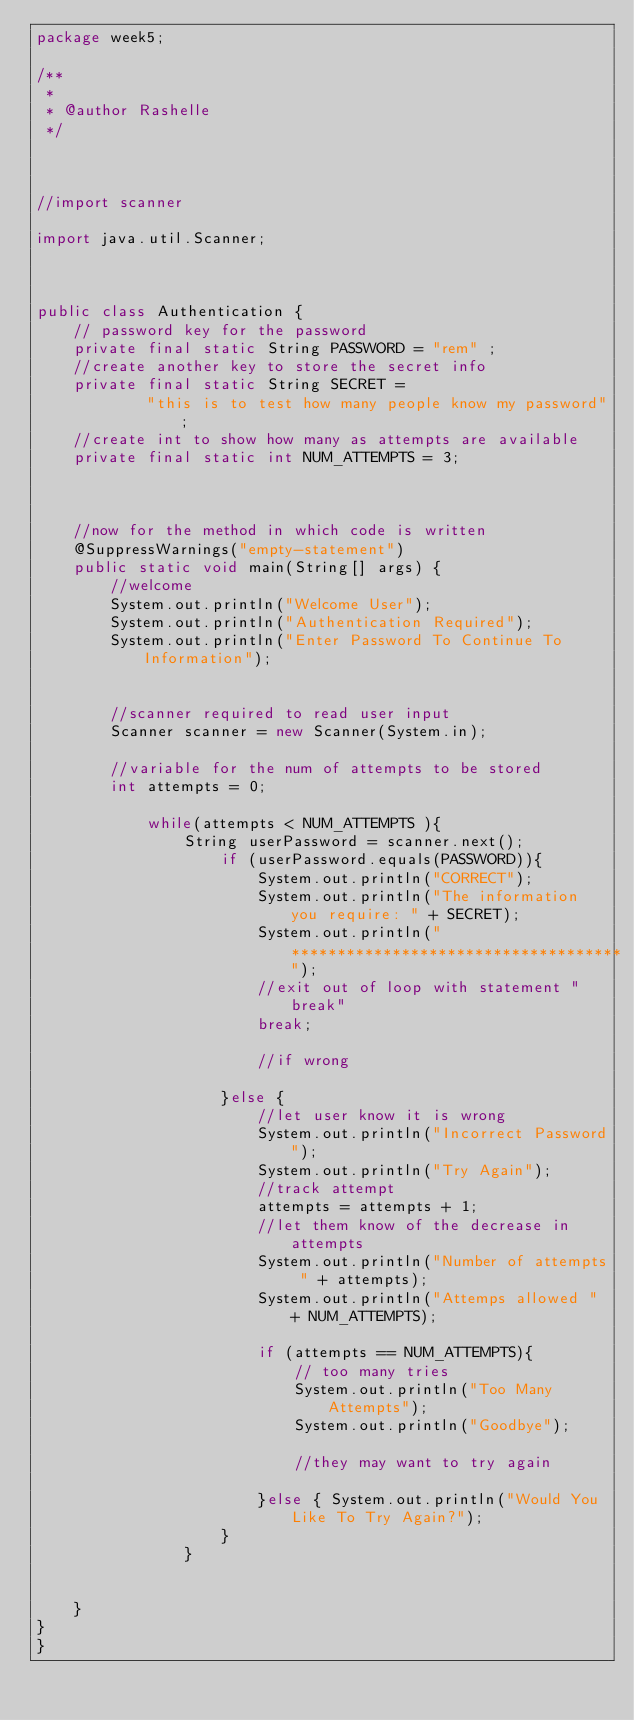Convert code to text. <code><loc_0><loc_0><loc_500><loc_500><_Java_>package week5;

/**
 *
 * @author Rashelle
 */



//import scanner

import java.util.Scanner;



public class Authentication {
    // password key for the password
    private final static String PASSWORD = "rem" ;
    //create another key to store the secret info
    private final static String SECRET = 
            "this is to test how many people know my password";
    //create int to show how many as attempts are available
    private final static int NUM_ATTEMPTS = 3;
    
   
    
    //now for the method in which code is written
    @SuppressWarnings("empty-statement")
    public static void main(String[] args) {
        //welcome
        System.out.println("Welcome User");
        System.out.println("Authentication Required");
        System.out.println("Enter Password To Continue To Information");
        
        
        //scanner required to read user input
        Scanner scanner = new Scanner(System.in);
        
        //variable for the num of attempts to be stored
        int attempts = 0;
        
            while(attempts < NUM_ATTEMPTS ){
                String userPassword = scanner.next();
                    if (userPassword.equals(PASSWORD)){
                        System.out.println("CORRECT");
                        System.out.println("The information you require: " + SECRET);
                        System.out.println("************************************");
                        //exit out of loop with statement "break"
                        break;
                        
                        //if wrong
                        
                    }else {
                        //let user know it is wrong
                        System.out.println("Incorrect Password");
                        System.out.println("Try Again");
                        //track attempt
                        attempts = attempts + 1;
                        //let them know of the decrease in attempts
                        System.out.println("Number of attempts " + attempts);
                        System.out.println("Attemps allowed " + NUM_ATTEMPTS);
                        
                        if (attempts == NUM_ATTEMPTS){
                            // too many tries
                            System.out.println("Too Many Attempts");
                            System.out.println("Goodbye");
                            
                            //they may want to try again
                       
                        }else { System.out.println("Would You Like To Try Again?");
                    }
                }
        
                   
    }
}
}</code> 